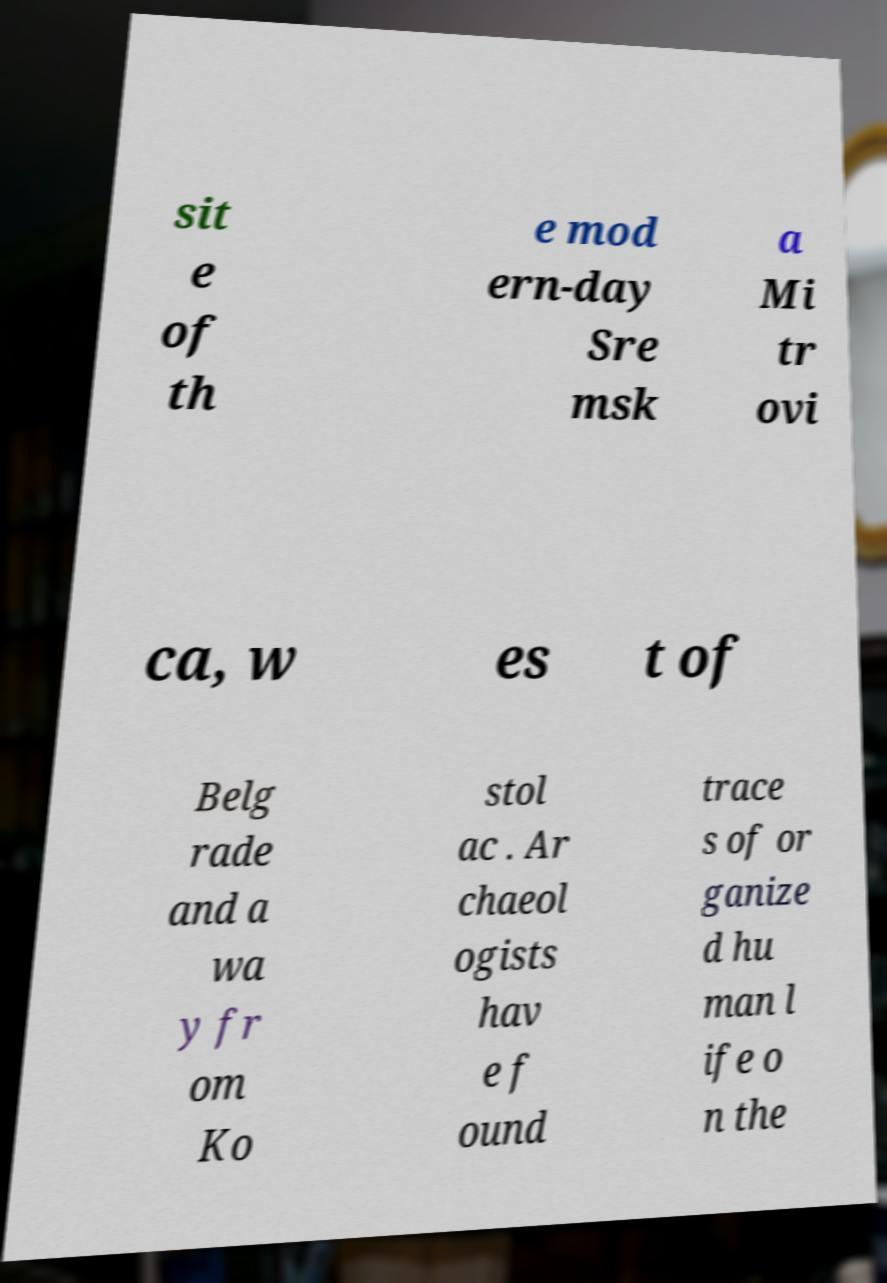What messages or text are displayed in this image? I need them in a readable, typed format. sit e of th e mod ern-day Sre msk a Mi tr ovi ca, w es t of Belg rade and a wa y fr om Ko stol ac . Ar chaeol ogists hav e f ound trace s of or ganize d hu man l ife o n the 